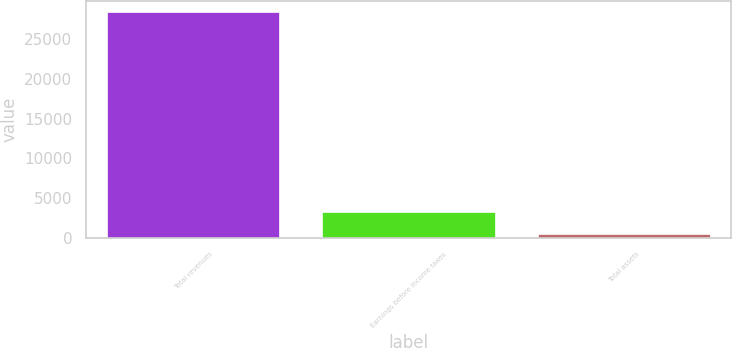Convert chart to OTSL. <chart><loc_0><loc_0><loc_500><loc_500><bar_chart><fcel>Total revenues<fcel>Earnings before income taxes<fcel>Total assets<nl><fcel>28375<fcel>3276.7<fcel>488<nl></chart> 